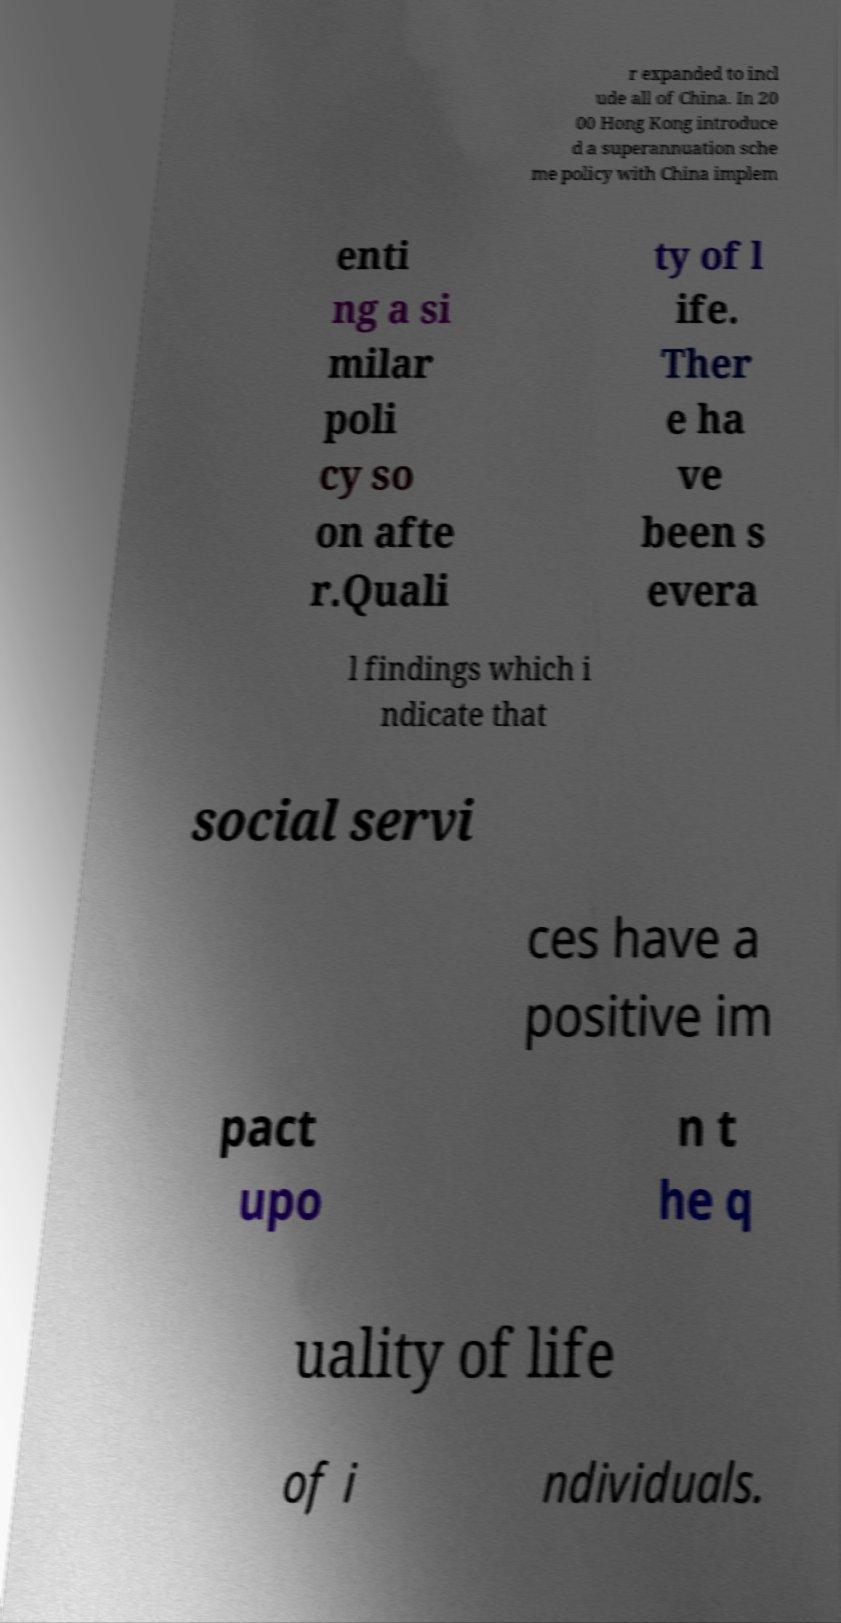For documentation purposes, I need the text within this image transcribed. Could you provide that? r expanded to incl ude all of China. In 20 00 Hong Kong introduce d a superannuation sche me policy with China implem enti ng a si milar poli cy so on afte r.Quali ty of l ife. Ther e ha ve been s evera l findings which i ndicate that social servi ces have a positive im pact upo n t he q uality of life of i ndividuals. 